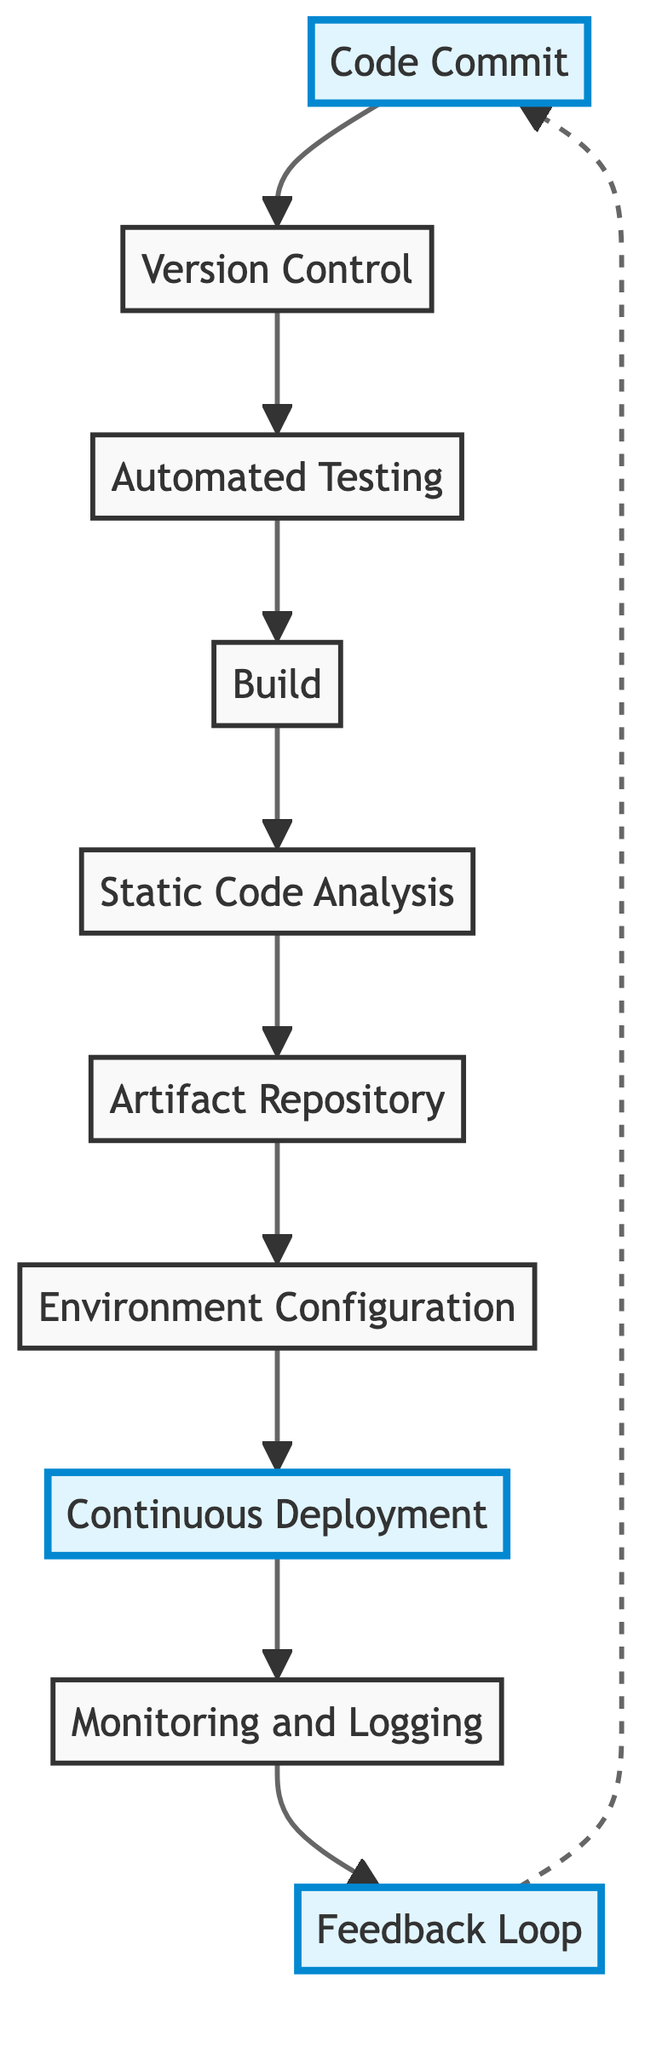What is the first step in the CI/CD pipeline? The first step in the CI/CD pipeline is "Code Commit," where developers commit code changes to a shared repository.
Answer: Code Commit How many elements are present in the diagram? Counting the elements listed, there are ten distinct steps in the CI/CD pipeline flowchart.
Answer: 10 What does the "Automated Testing" step verify? The "Automated Testing" step runs unit and integration tests to verify the new code's correctness after it is committed and managed via version control.
Answer: Code correctness What follows the "Build" stage in the CI/CD pipeline? After the "Build" stage, the next step is "Static Code Analysis," which involves analyzing the code quality and ensuring coding standards.
Answer: Static Code Analysis Identify the step that involves gathering user feedback. The step involving gathering user feedback is the "Feedback Loop," which helps in continually improving the system based on user interactions.
Answer: Feedback Loop What tools might be used for environment configuration? Tools commonly used for environment configuration include Ansible or Terraform as mentioned in the description of the "Environment Configuration" step.
Answer: Ansible or Terraform Which stage automatically deploys artifacts to various environments? The stage that automatically deploys artifacts is called "Continuous Deployment," which utilizes CI/CD tools to handle the deployment process.
Answer: Continuous Deployment How are built artifacts stored for later deployment? Built artifacts are stored in an "Artifact Repository" like Nexus or JFrog Artifactory, as indicated in the flowchart.
Answer: Artifact Repository What is the relationship between "Monitoring and Logging" and "Continuous Deployment"? "Monitoring and Logging" comes after "Continuous Deployment," as it involves tracking the performance and behaviors of the deployed application.
Answer: Sequential Which step is highlighted as the starting point of the CI/CD process? The highlighted starting point of the CI/CD process is "Code Commit," where input begins the CI/CD pipeline.
Answer: Code Commit 